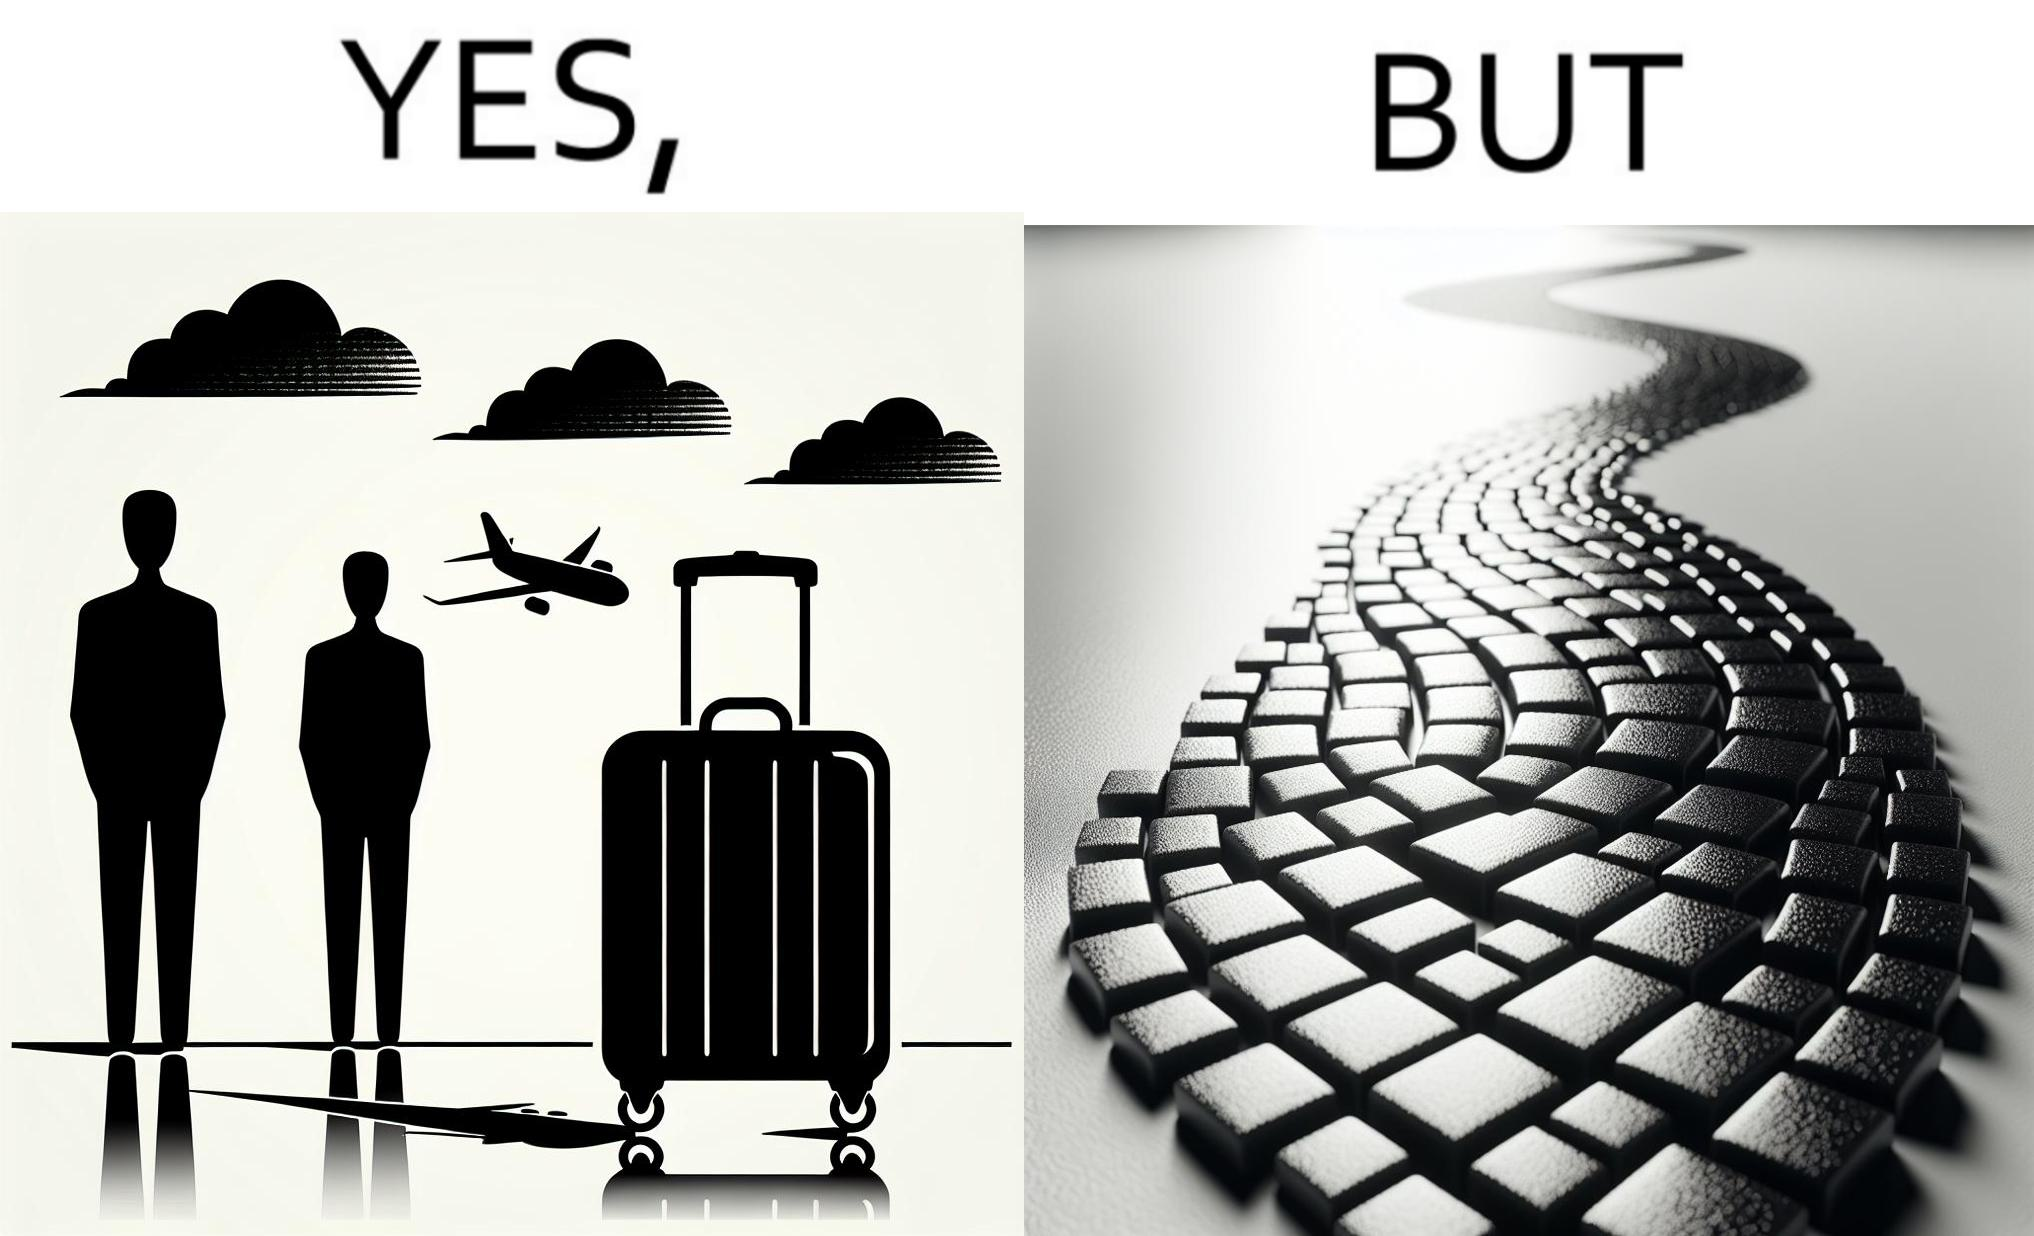What do you see in each half of this image? In the left part of the image: it is a trolley luggage bag In the right part of the image: It is a cobblestone road 